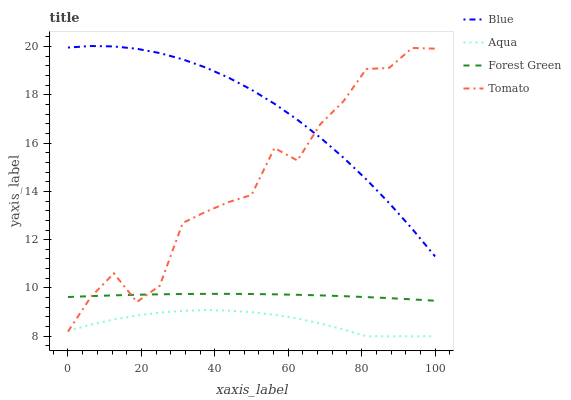Does Aqua have the minimum area under the curve?
Answer yes or no. Yes. Does Blue have the maximum area under the curve?
Answer yes or no. Yes. Does Tomato have the minimum area under the curve?
Answer yes or no. No. Does Tomato have the maximum area under the curve?
Answer yes or no. No. Is Forest Green the smoothest?
Answer yes or no. Yes. Is Tomato the roughest?
Answer yes or no. Yes. Is Tomato the smoothest?
Answer yes or no. No. Is Forest Green the roughest?
Answer yes or no. No. Does Aqua have the lowest value?
Answer yes or no. Yes. Does Tomato have the lowest value?
Answer yes or no. No. Does Blue have the highest value?
Answer yes or no. Yes. Does Tomato have the highest value?
Answer yes or no. No. Is Aqua less than Forest Green?
Answer yes or no. Yes. Is Blue greater than Forest Green?
Answer yes or no. Yes. Does Tomato intersect Blue?
Answer yes or no. Yes. Is Tomato less than Blue?
Answer yes or no. No. Is Tomato greater than Blue?
Answer yes or no. No. Does Aqua intersect Forest Green?
Answer yes or no. No. 